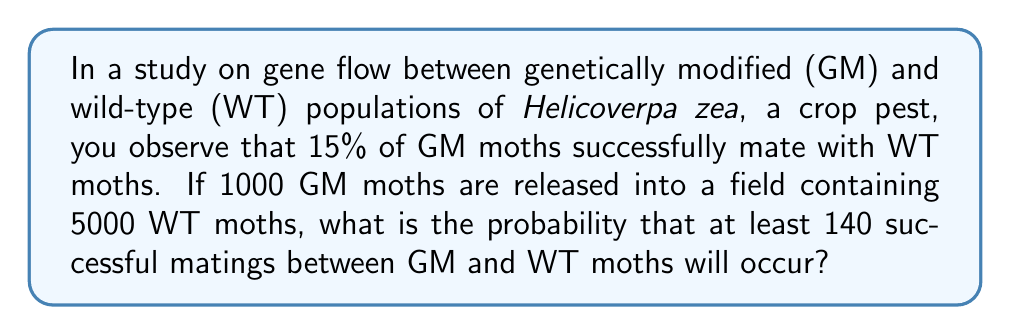What is the answer to this math problem? Let's approach this step-by-step:

1) First, we need to identify the probability distribution that models this scenario. Since we have a large number of trials (1000 GM moths) and each trial has a small probability of success (15% chance of mating with WT), this follows a Binomial distribution that can be approximated by a Normal distribution.

2) Let X be the number of successful matings. Then X ~ B(n, p), where:
   n = 1000 (number of GM moths)
   p = 0.15 (probability of successful mating)

3) We want to find P(X ≥ 140)

4) The mean of this distribution is:
   $$\mu = np = 1000 \times 0.15 = 150$$

5) The standard deviation is:
   $$\sigma = \sqrt{np(1-p)} = \sqrt{1000 \times 0.15 \times 0.85} = \sqrt{127.5} \approx 11.29$$

6) To use the normal approximation, we need to apply a continuity correction. We're looking for P(X ≥ 140), so we use 139.5 as the lower bound.

7) We can now calculate the z-score:
   $$z = \frac{139.5 - 150}{11.29} \approx -0.93$$

8) Using a standard normal table or calculator, we can find the area to the right of z = -0.93:
   P(Z > -0.93) ≈ 0.8238

Therefore, the probability of at least 140 successful matings is approximately 0.8238 or 82.38%.
Answer: 0.8238 